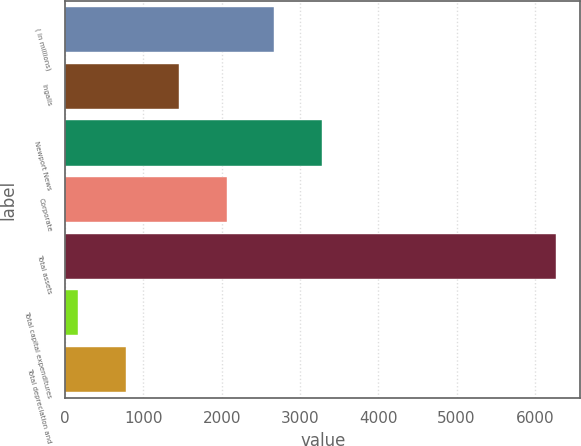Convert chart to OTSL. <chart><loc_0><loc_0><loc_500><loc_500><bar_chart><fcel>( in millions)<fcel>Ingalls<fcel>Newport News<fcel>Corporate<fcel>Total assets<fcel>Total capital expenditures<fcel>Total depreciation and<nl><fcel>2672.8<fcel>1452<fcel>3283.2<fcel>2062.4<fcel>6269<fcel>165<fcel>775.4<nl></chart> 